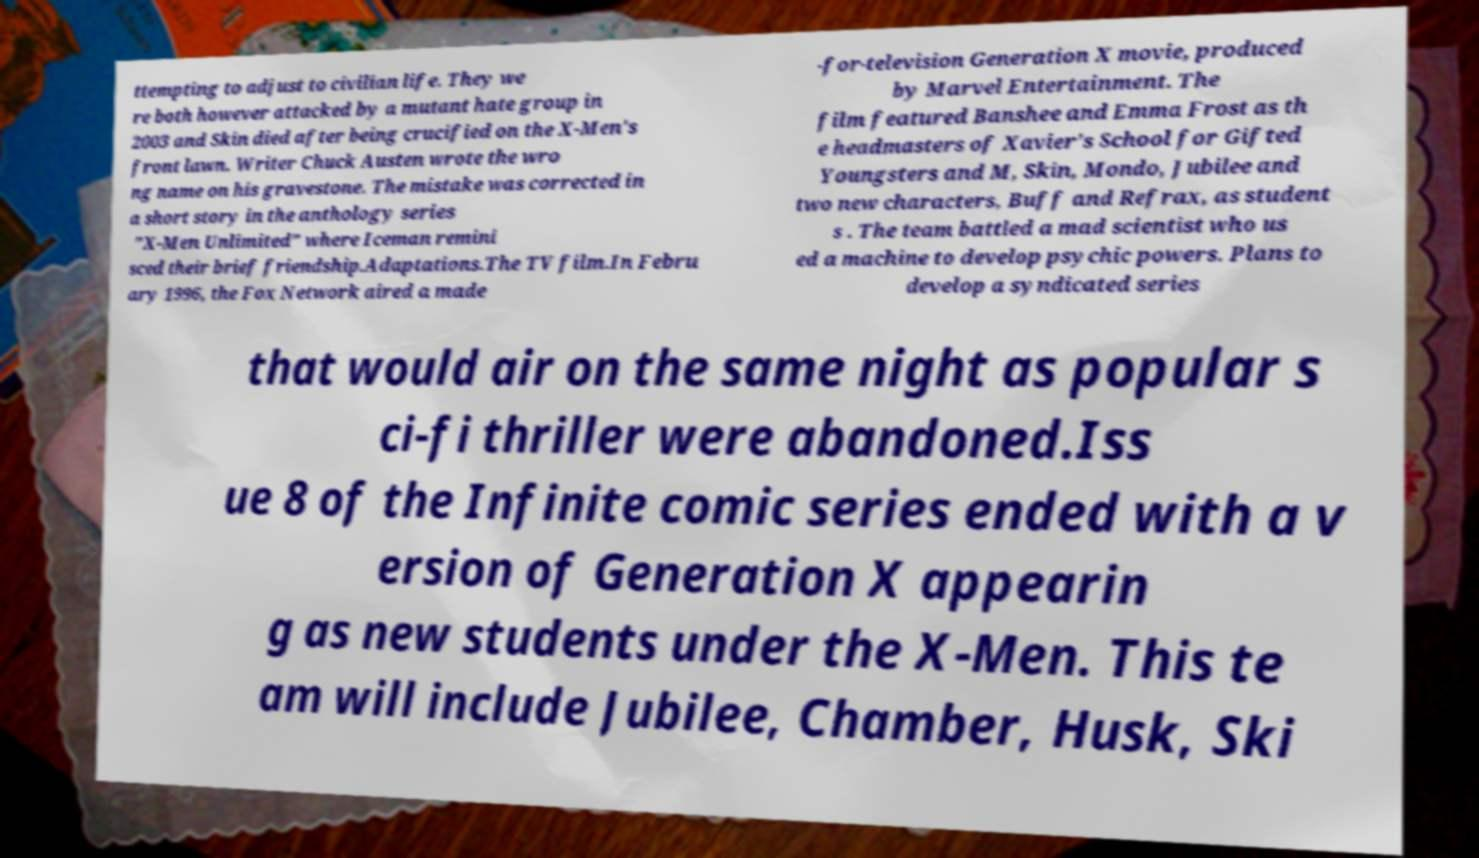Could you assist in decoding the text presented in this image and type it out clearly? ttempting to adjust to civilian life. They we re both however attacked by a mutant hate group in 2003 and Skin died after being crucified on the X-Men's front lawn. Writer Chuck Austen wrote the wro ng name on his gravestone. The mistake was corrected in a short story in the anthology series "X-Men Unlimited" where Iceman remini sced their brief friendship.Adaptations.The TV film.In Febru ary 1996, the Fox Network aired a made -for-television Generation X movie, produced by Marvel Entertainment. The film featured Banshee and Emma Frost as th e headmasters of Xavier's School for Gifted Youngsters and M, Skin, Mondo, Jubilee and two new characters, Buff and Refrax, as student s . The team battled a mad scientist who us ed a machine to develop psychic powers. Plans to develop a syndicated series that would air on the same night as popular s ci-fi thriller were abandoned.Iss ue 8 of the Infinite comic series ended with a v ersion of Generation X appearin g as new students under the X-Men. This te am will include Jubilee, Chamber, Husk, Ski 